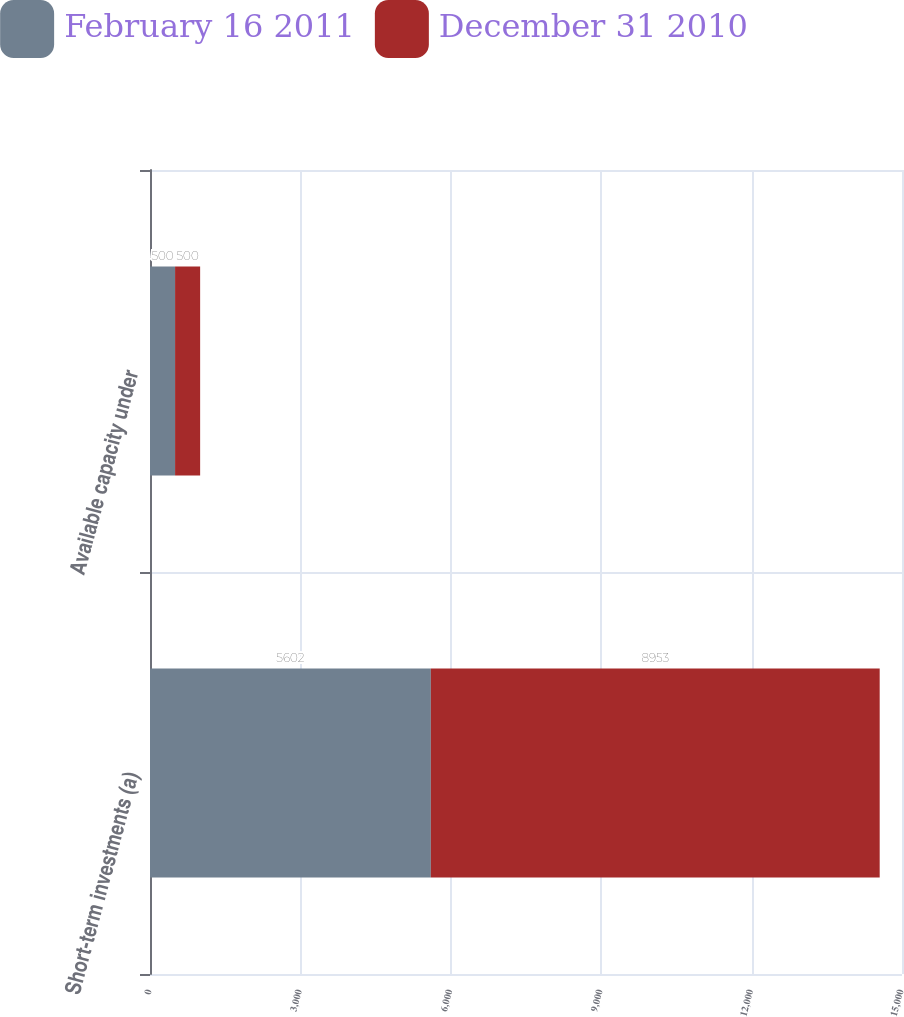Convert chart. <chart><loc_0><loc_0><loc_500><loc_500><stacked_bar_chart><ecel><fcel>Short-term investments (a)<fcel>Available capacity under<nl><fcel>February 16 2011<fcel>5602<fcel>500<nl><fcel>December 31 2010<fcel>8953<fcel>500<nl></chart> 